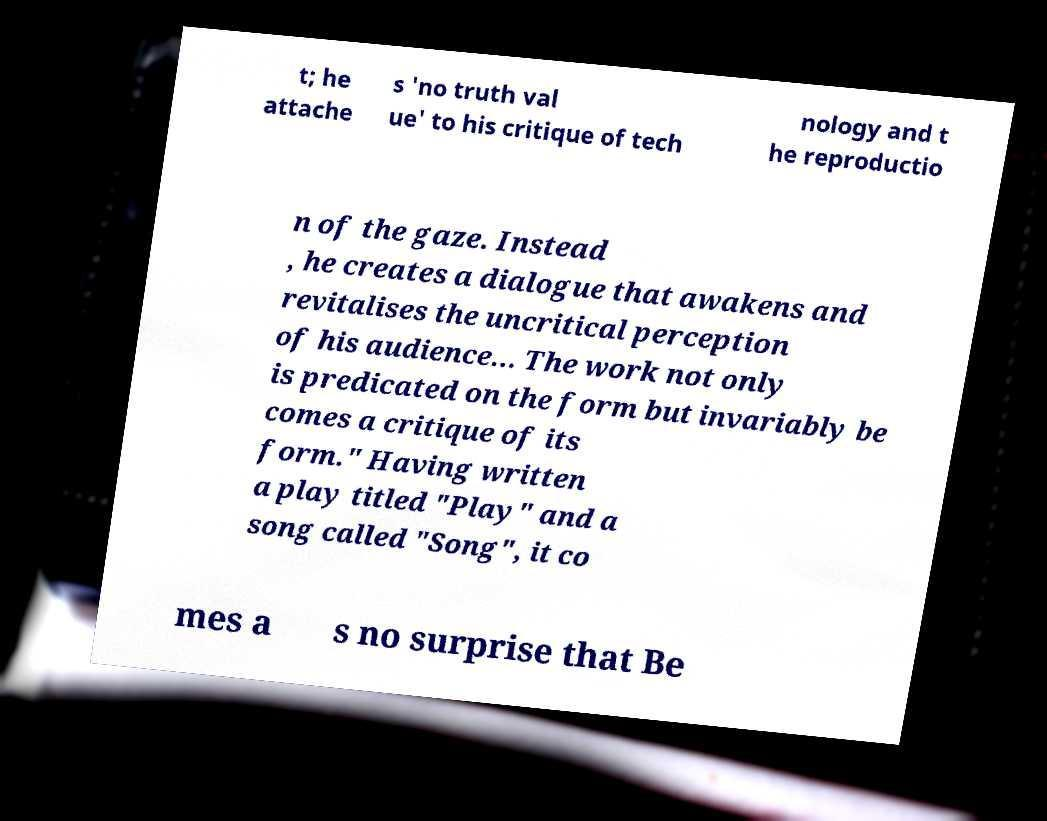I need the written content from this picture converted into text. Can you do that? t; he attache s 'no truth val ue' to his critique of tech nology and t he reproductio n of the gaze. Instead , he creates a dialogue that awakens and revitalises the uncritical perception of his audience... The work not only is predicated on the form but invariably be comes a critique of its form." Having written a play titled "Play" and a song called "Song", it co mes a s no surprise that Be 